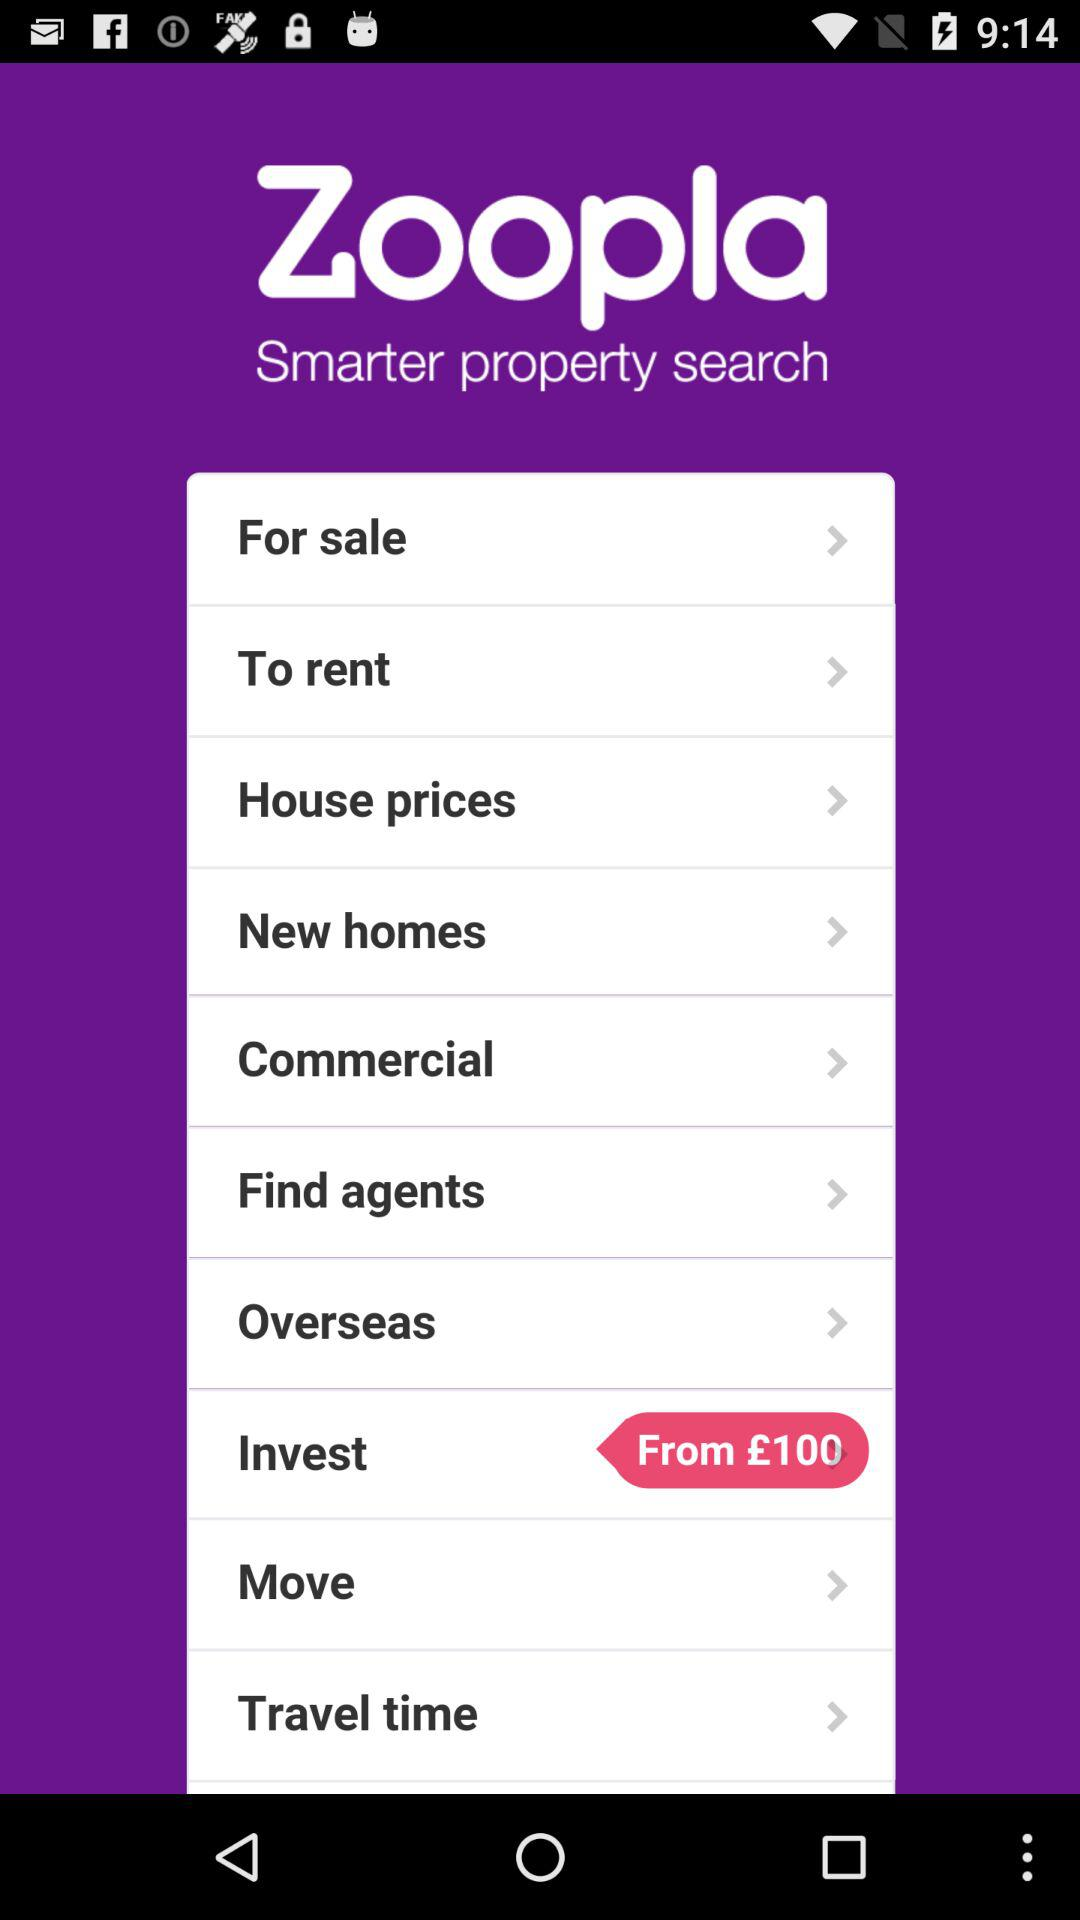Where does the user want to move?
When the provided information is insufficient, respond with <no answer>. <no answer> 